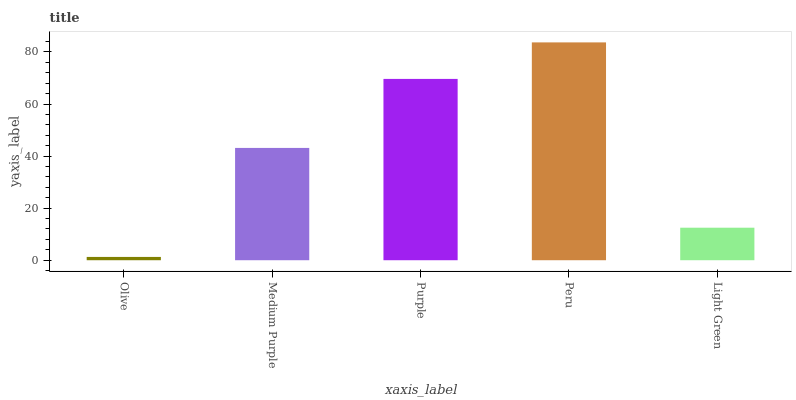Is Olive the minimum?
Answer yes or no. Yes. Is Peru the maximum?
Answer yes or no. Yes. Is Medium Purple the minimum?
Answer yes or no. No. Is Medium Purple the maximum?
Answer yes or no. No. Is Medium Purple greater than Olive?
Answer yes or no. Yes. Is Olive less than Medium Purple?
Answer yes or no. Yes. Is Olive greater than Medium Purple?
Answer yes or no. No. Is Medium Purple less than Olive?
Answer yes or no. No. Is Medium Purple the high median?
Answer yes or no. Yes. Is Medium Purple the low median?
Answer yes or no. Yes. Is Olive the high median?
Answer yes or no. No. Is Purple the low median?
Answer yes or no. No. 